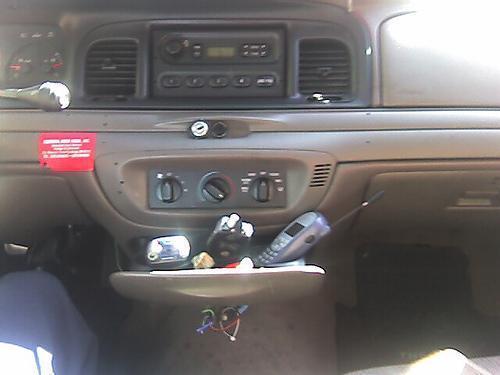How many cows are facing the ocean?
Give a very brief answer. 0. 